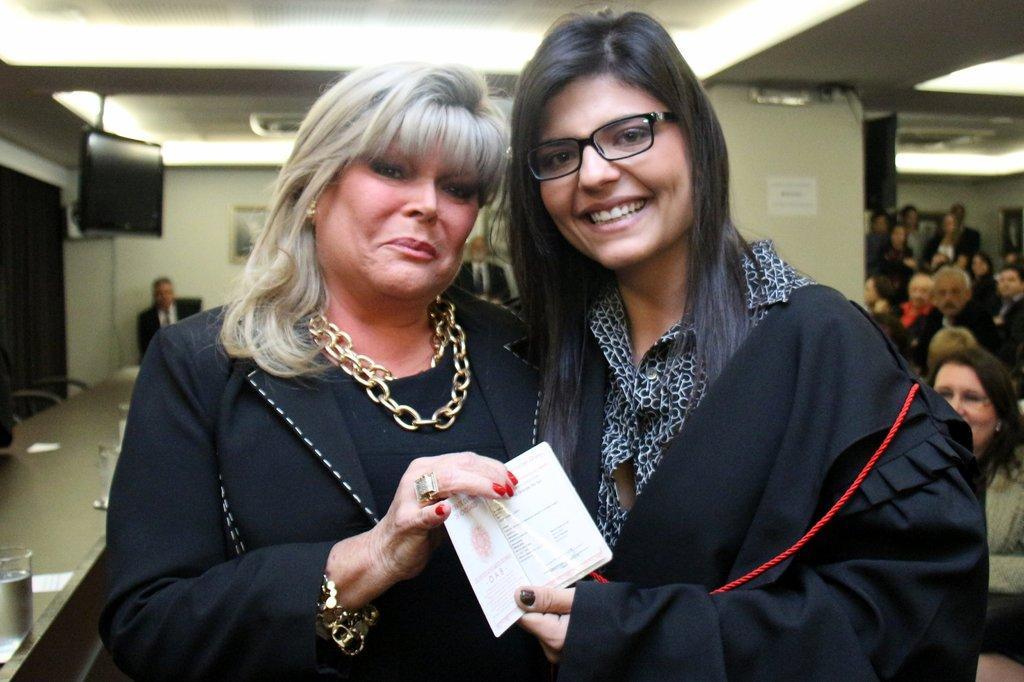In one or two sentences, can you explain what this image depicts? In the center of the image, we can see two ladies holding a card and one of them is wearing glasses and other is wearing chains. In the background, we can see screens, tables, chairs, glasses and some other people and we can see posters and there are lights. At the bottom, there is floor. 